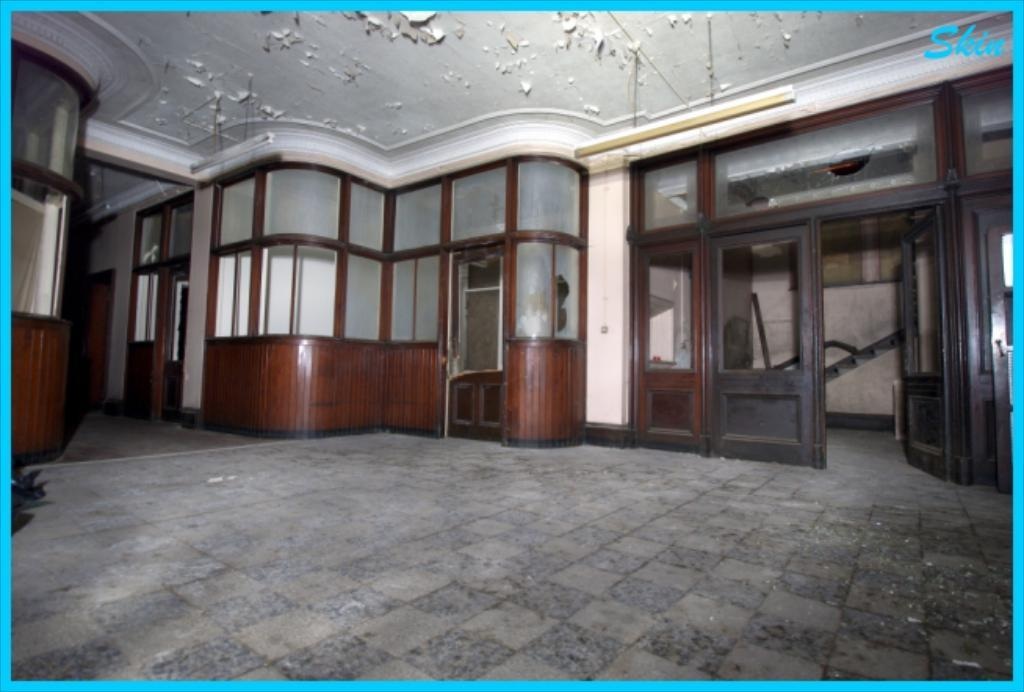What type of view does the image provide? The image provides an inside view of houses. What can be seen on the exterior of the houses in the image? Doors are visible in the image. What separates the rooms within the houses? Walls are present in the image. What covers the top of the houses in the image? The roof is visible in the image. What type of leather is used to cover the walls in the image? There is no leather present in the image; the walls are made of a different material. 